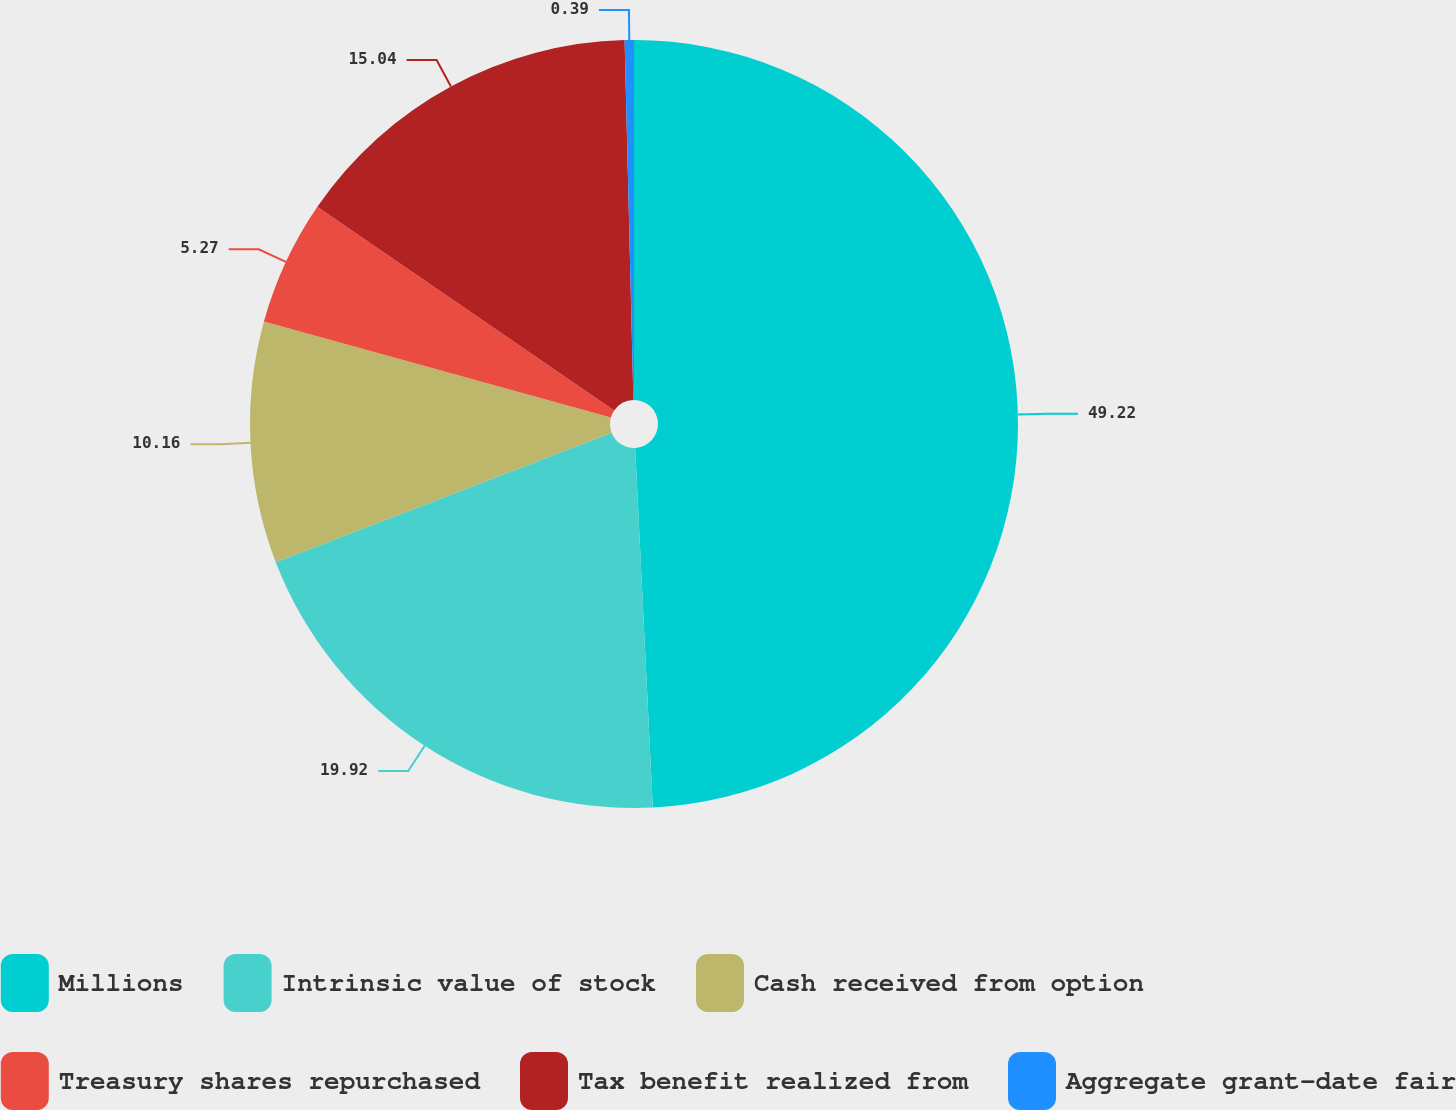Convert chart to OTSL. <chart><loc_0><loc_0><loc_500><loc_500><pie_chart><fcel>Millions<fcel>Intrinsic value of stock<fcel>Cash received from option<fcel>Treasury shares repurchased<fcel>Tax benefit realized from<fcel>Aggregate grant-date fair<nl><fcel>49.22%<fcel>19.92%<fcel>10.16%<fcel>5.27%<fcel>15.04%<fcel>0.39%<nl></chart> 